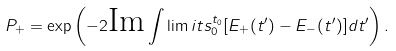Convert formula to latex. <formula><loc_0><loc_0><loc_500><loc_500>P _ { + } = \exp \left ( - 2 \text {Im} \int \lim i t s _ { 0 } ^ { t _ { 0 } } [ E _ { + } ( t ^ { \prime } ) - E _ { - } ( t ^ { \prime } ) ] d t ^ { \prime } \right ) .</formula> 